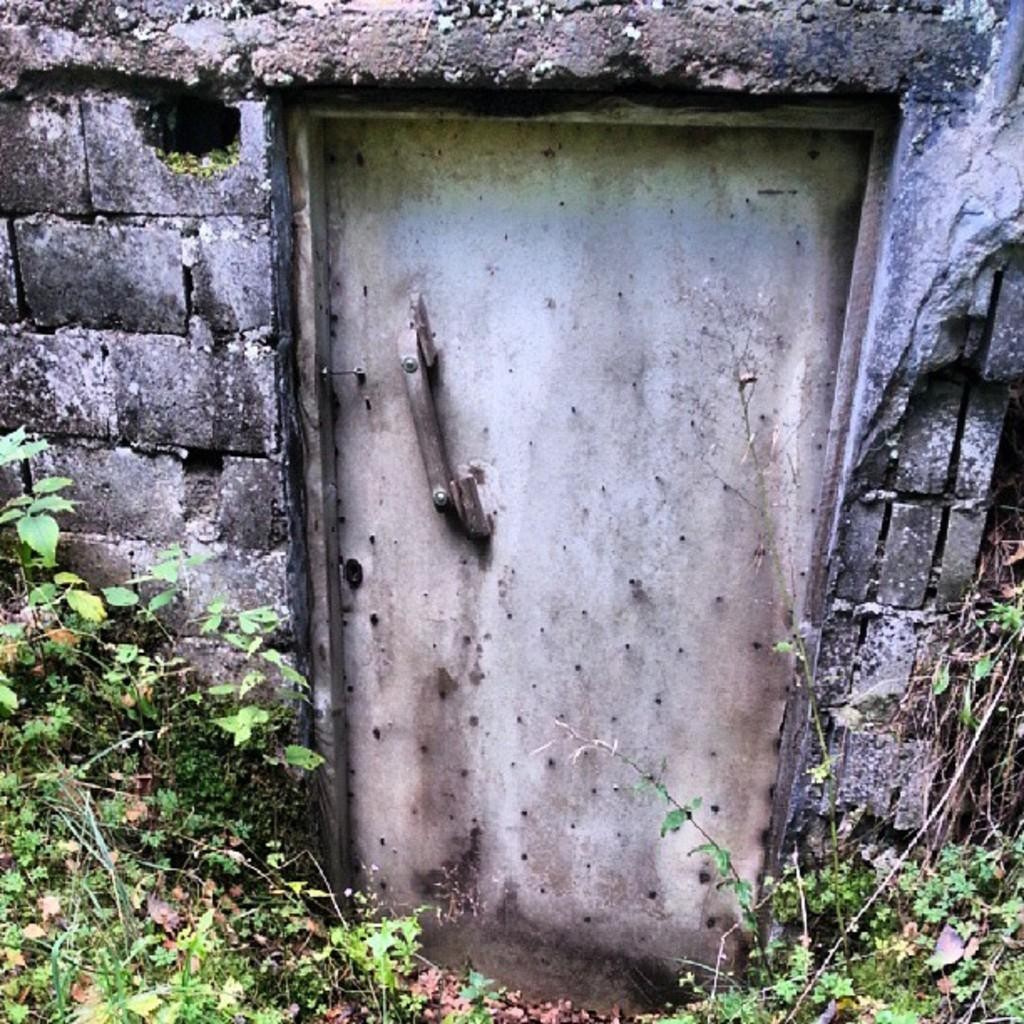What type of structure is present in the image? There is a wall in the image. What is attached to the wall? There is a metal door on the wall. What type of vegetation can be seen in the image? Plants are visible in the image. What color is the hair on the cherry in the image? There is no cherry or hair present in the image. 